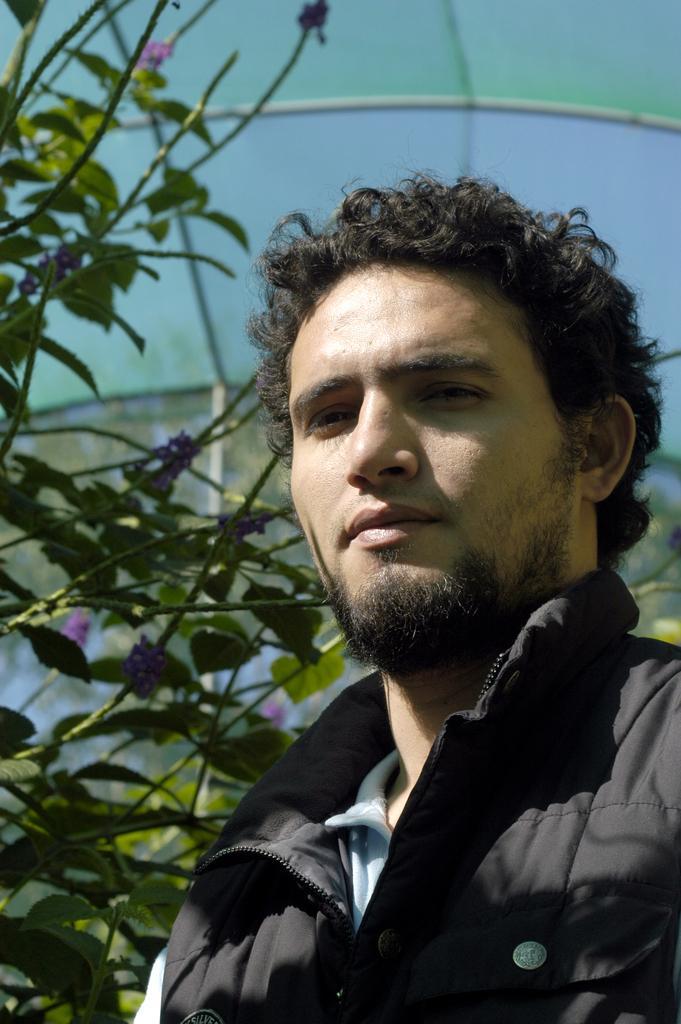How would you summarize this image in a sentence or two? In this picture we can see a person and few plants in the background. 